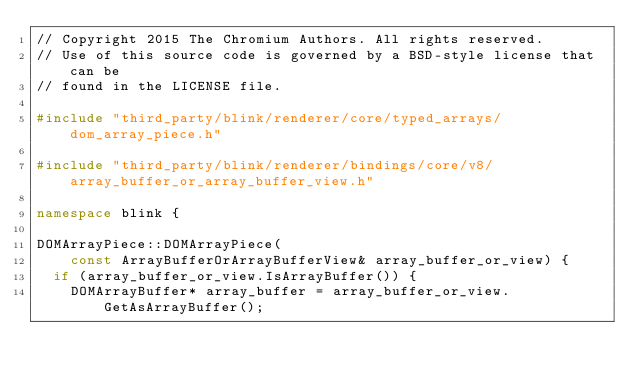Convert code to text. <code><loc_0><loc_0><loc_500><loc_500><_C++_>// Copyright 2015 The Chromium Authors. All rights reserved.
// Use of this source code is governed by a BSD-style license that can be
// found in the LICENSE file.

#include "third_party/blink/renderer/core/typed_arrays/dom_array_piece.h"

#include "third_party/blink/renderer/bindings/core/v8/array_buffer_or_array_buffer_view.h"

namespace blink {

DOMArrayPiece::DOMArrayPiece(
    const ArrayBufferOrArrayBufferView& array_buffer_or_view) {
  if (array_buffer_or_view.IsArrayBuffer()) {
    DOMArrayBuffer* array_buffer = array_buffer_or_view.GetAsArrayBuffer();</code> 